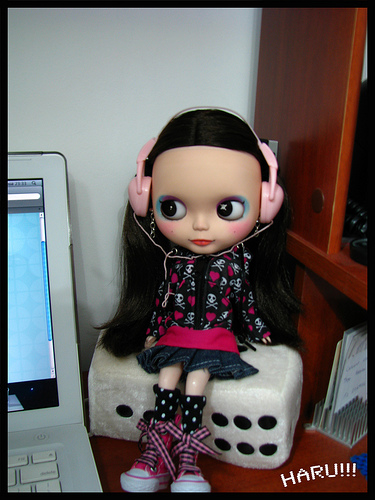<image>
Can you confirm if the doll is on the dice? Yes. Looking at the image, I can see the doll is positioned on top of the dice, with the dice providing support. Is the doll in front of the computer? No. The doll is not in front of the computer. The spatial positioning shows a different relationship between these objects. Where is the toy in relation to the laptop? Is it in front of the laptop? No. The toy is not in front of the laptop. The spatial positioning shows a different relationship between these objects. Is there a headphones above the die? Yes. The headphones is positioned above the die in the vertical space, higher up in the scene. 